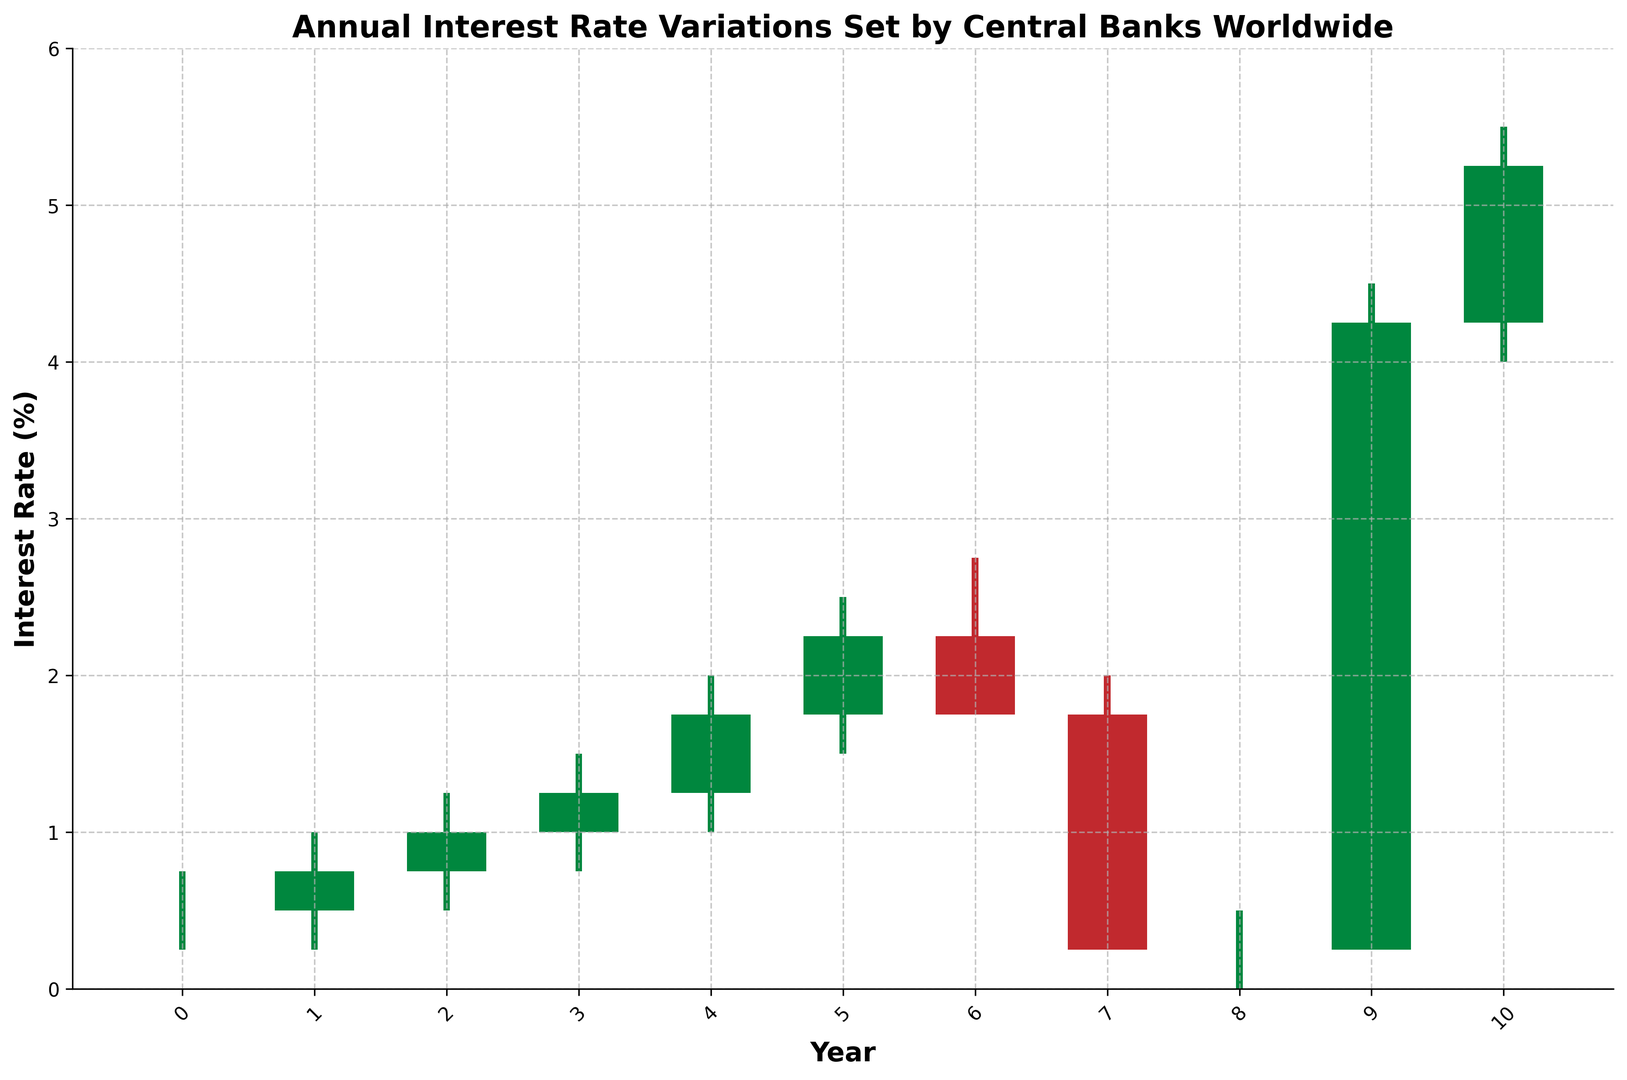What's the highest interest rate recorded in the data? The highest interest rate recorded in the data is represented by the highest point of the candlestick bars. From the figure, the highest point is in 2023 at 5.50%.
Answer: 5.50% Which years have a closing interest rate higher than the opening interest rate? The years in which the closing interest rate is higher than the opening interest rate are shown where the candlestick bar is green. From the figure, the green candlestick bars are in 2014, 2015, 2016, 2017, and 2018.
Answer: 2014, 2015, 2016, 2017, 2018 How does the interest rate change from 2019 to 2020? To determine the interest rate change from 2019 to 2020, compare the closing rate of 2019 with the closing rate of 2020. The closing rate for 2019 is 1.75%, and for 2020 it's 0.25%. This shows a decrease of 1.50%.
Answer: Decreased by 1.50% What was the interest rate range in 2022? The interest rate range for any year is calculated by subtracting the low value from the high value. For 2022, the high value is 4.50% and the low value is 0.25%. Thus, the range is 4.50% - 0.25% = 4.25%.
Answer: 4.25% Which year shows the maximum increase in interest rate from open to close? The maximum increase is determined by finding the difference between close and open values and identifying the year with the highest positive difference. In 2022, the open rate is 0.25% and the close rate is 4.25%, showing an increase of 4.00%, the highest in the dataset.
Answer: 2022 Compare the interest rate trend in the years 2018 and 2019. Did it show an increase, decrease, or remain the same? For trend comparison, check the closing rates of both years. In 2018, the close rate is 2.25%, while in 2019, it is 1.75%. This shows a decrease from 2018 to 2019.
Answer: Decrease Which year had the smallest difference between the high and low interest rates? The smallest difference is found by subtracting the low value from the high value for each year and identifying the smallest result. In 2020, the high is 2.00% and the low is 0.25%, giving a difference of 1.75%, which is the smallest.
Answer: 2020 In which year did the interest rate decrease the most from open to close? The year with the largest decrease is determined by calculating the difference between open and close values and finding the most negative difference. In 2020, open is 1.75% and close is 0.25%, showing a decrease of 1.50%, the highest negative difference.
Answer: 2020 